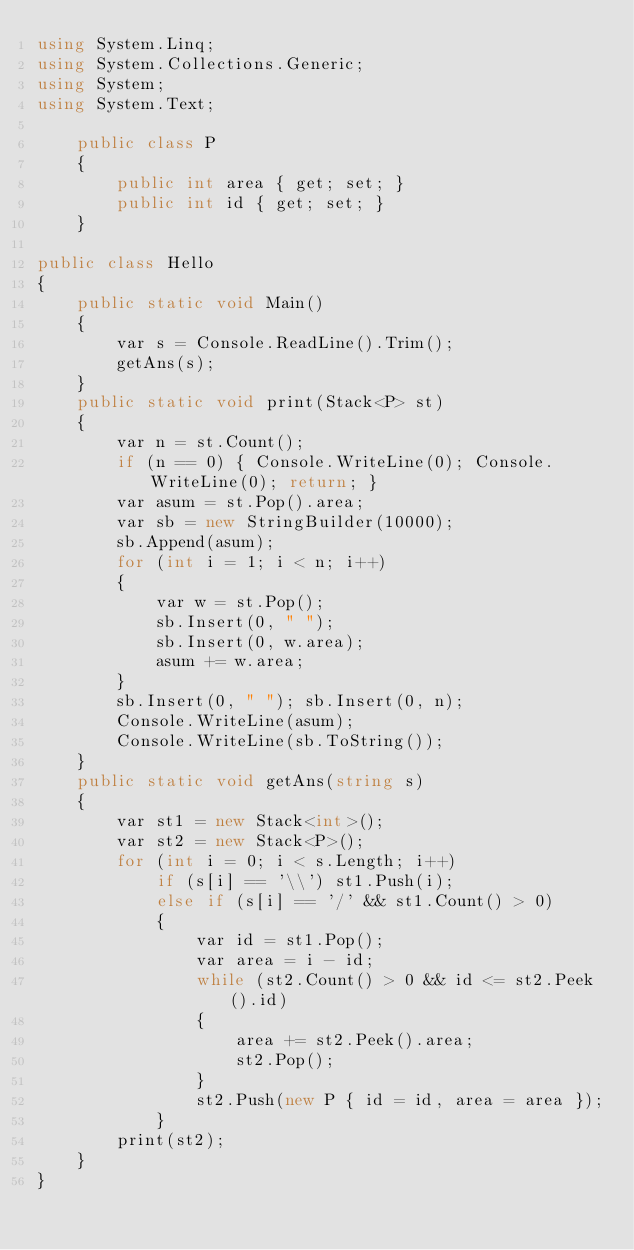<code> <loc_0><loc_0><loc_500><loc_500><_C#_>using System.Linq;
using System.Collections.Generic;
using System;
using System.Text;

    public class P
    {
        public int area { get; set; }
        public int id { get; set; }
    }

public class Hello
{
    public static void Main()
    {
        var s = Console.ReadLine().Trim();
        getAns(s);
    }
    public static void print(Stack<P> st)
    {
        var n = st.Count();
        if (n == 0) { Console.WriteLine(0); Console.WriteLine(0); return; }
        var asum = st.Pop().area;
        var sb = new StringBuilder(10000);
        sb.Append(asum);
        for (int i = 1; i < n; i++)
        {
            var w = st.Pop();
            sb.Insert(0, " ");
            sb.Insert(0, w.area);
            asum += w.area;
        }
        sb.Insert(0, " "); sb.Insert(0, n);
        Console.WriteLine(asum);
        Console.WriteLine(sb.ToString());
    }
    public static void getAns(string s)
    {
        var st1 = new Stack<int>();
        var st2 = new Stack<P>();
        for (int i = 0; i < s.Length; i++)
            if (s[i] == '\\') st1.Push(i);
            else if (s[i] == '/' && st1.Count() > 0)
            {
                var id = st1.Pop();
                var area = i - id;
                while (st2.Count() > 0 && id <= st2.Peek().id)
                {
                    area += st2.Peek().area;
                    st2.Pop();
                }
                st2.Push(new P { id = id, area = area });
            }
        print(st2);
    }
}

</code> 